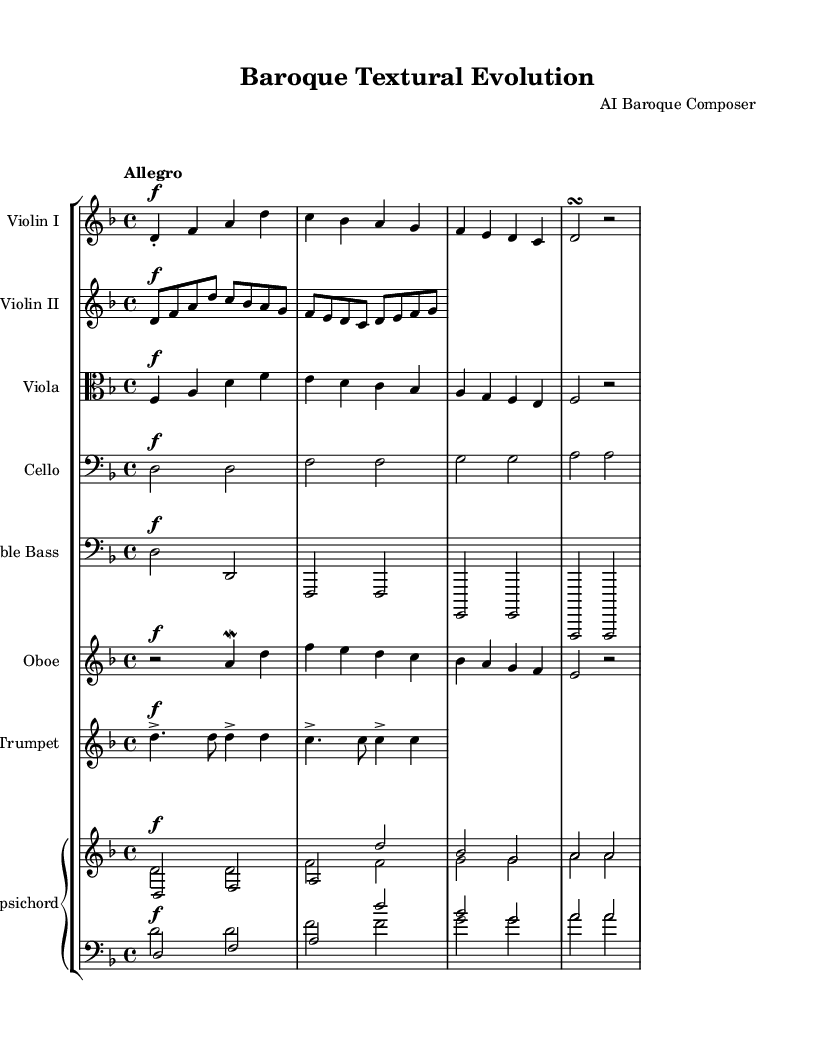What is the key signature of this music? The key signature is indicated at the beginning of the score, showing two flats (B and E), which signifies the key of D minor.
Answer: D minor What is the time signature of this piece? The time signature is found at the beginning of the score, displaying a 4 over 4, indicating that there are four beats per measure.
Answer: 4/4 What is the tempo marking of the piece? The tempo marking is shown at the start with the word "Allegro," which typically suggests a fast and lively tempo.
Answer: Allegro How many different string instruments are present in the score? The score includes three different string instruments: Violin I, Violin II, Viola, Cello, and Double Bass, totaling five string instruments.
Answer: Five Which wind instrument is featured in this piece? The score includes the Oboe as the wind instrument, as indicated by its own staff in the music sheet.
Answer: Oboe What is the role of the harpsichord in this piece? The harpsichord functions as the continuo instrument, providing harmonic support and accompaniment indicated by the two staves in the score.
Answer: Continuo What is the highest note in the Violin I part? By analyzing the notation for Violin I, the highest note appears to be "a," as observed in the initial measures of the part.
Answer: A 